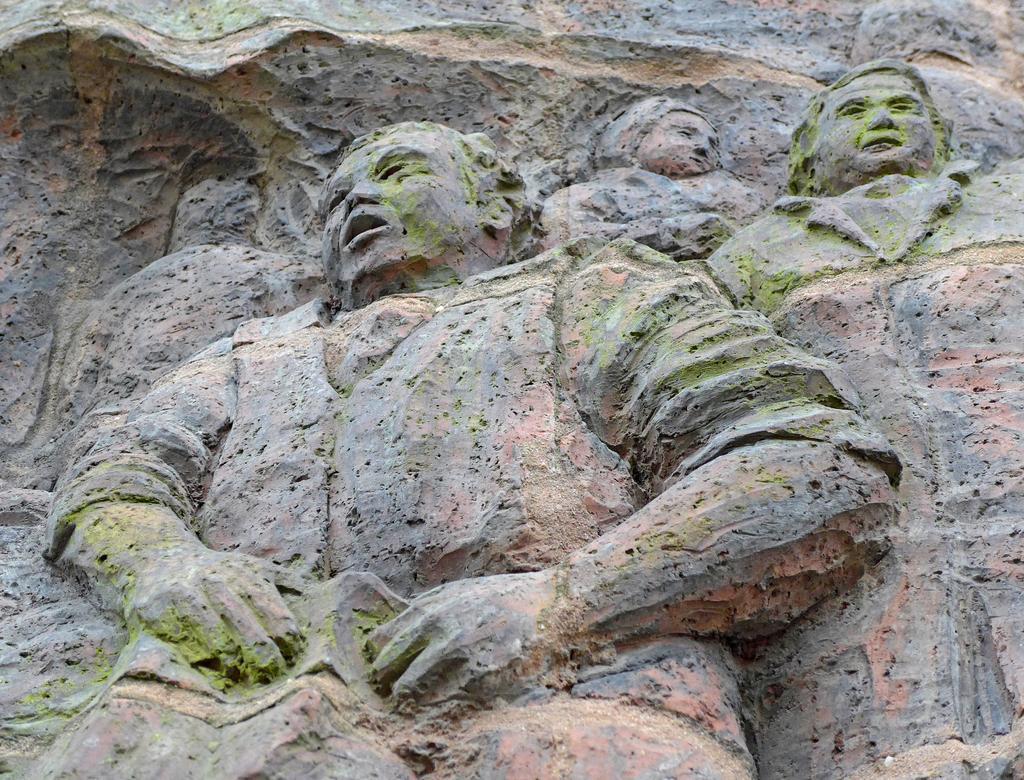Can you describe this image briefly? In this image we can see the stone sculptures. 